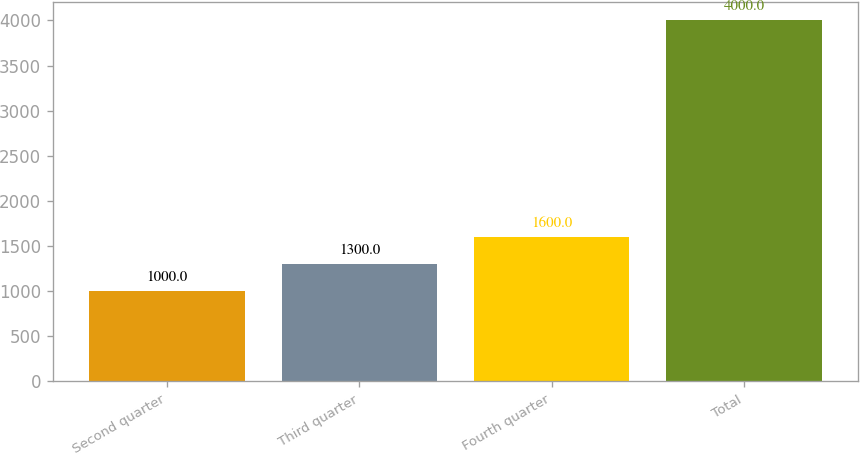Convert chart to OTSL. <chart><loc_0><loc_0><loc_500><loc_500><bar_chart><fcel>Second quarter<fcel>Third quarter<fcel>Fourth quarter<fcel>Total<nl><fcel>1000<fcel>1300<fcel>1600<fcel>4000<nl></chart> 